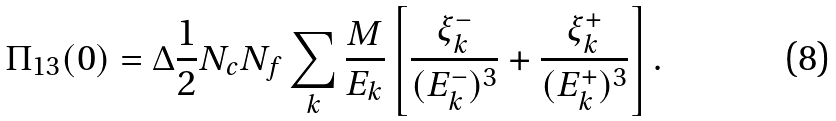<formula> <loc_0><loc_0><loc_500><loc_500>\Pi _ { 1 3 } ( 0 ) = \Delta \frac { 1 } { 2 } N _ { c } N _ { f } \sum _ { k } \frac { M } { E _ { k } } \left [ \frac { \xi _ { k } ^ { - } } { ( E _ { k } ^ { - } ) ^ { 3 } } + \frac { \xi _ { k } ^ { + } } { ( E _ { k } ^ { + } ) ^ { 3 } } \right ] .</formula> 